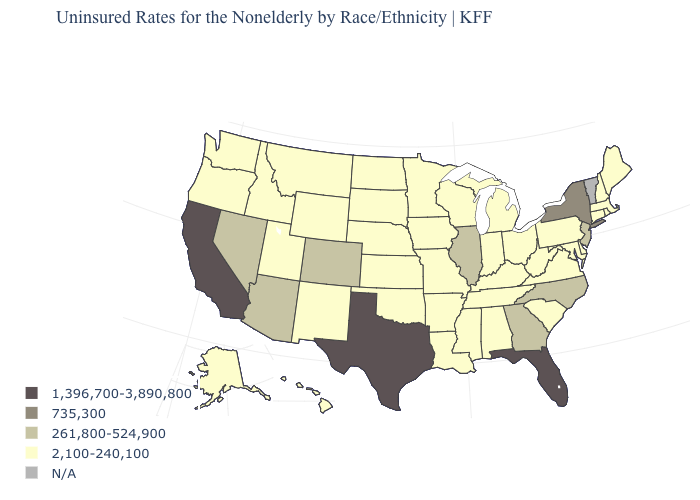Does Illinois have the highest value in the MidWest?
Write a very short answer. Yes. What is the value of Iowa?
Answer briefly. 2,100-240,100. Which states hav the highest value in the West?
Give a very brief answer. California. Which states have the lowest value in the Northeast?
Short answer required. Connecticut, Maine, Massachusetts, New Hampshire, Pennsylvania, Rhode Island. What is the value of Oregon?
Short answer required. 2,100-240,100. Name the states that have a value in the range 261,800-524,900?
Short answer required. Arizona, Colorado, Georgia, Illinois, Nevada, New Jersey, North Carolina. Name the states that have a value in the range N/A?
Write a very short answer. Vermont. Is the legend a continuous bar?
Be succinct. No. Which states have the highest value in the USA?
Short answer required. California, Florida, Texas. Does Florida have the highest value in the South?
Be succinct. Yes. Does Wyoming have the highest value in the West?
Give a very brief answer. No. Among the states that border Colorado , does Wyoming have the highest value?
Give a very brief answer. No. Which states have the highest value in the USA?
Short answer required. California, Florida, Texas. What is the value of Minnesota?
Be succinct. 2,100-240,100. Is the legend a continuous bar?
Answer briefly. No. 